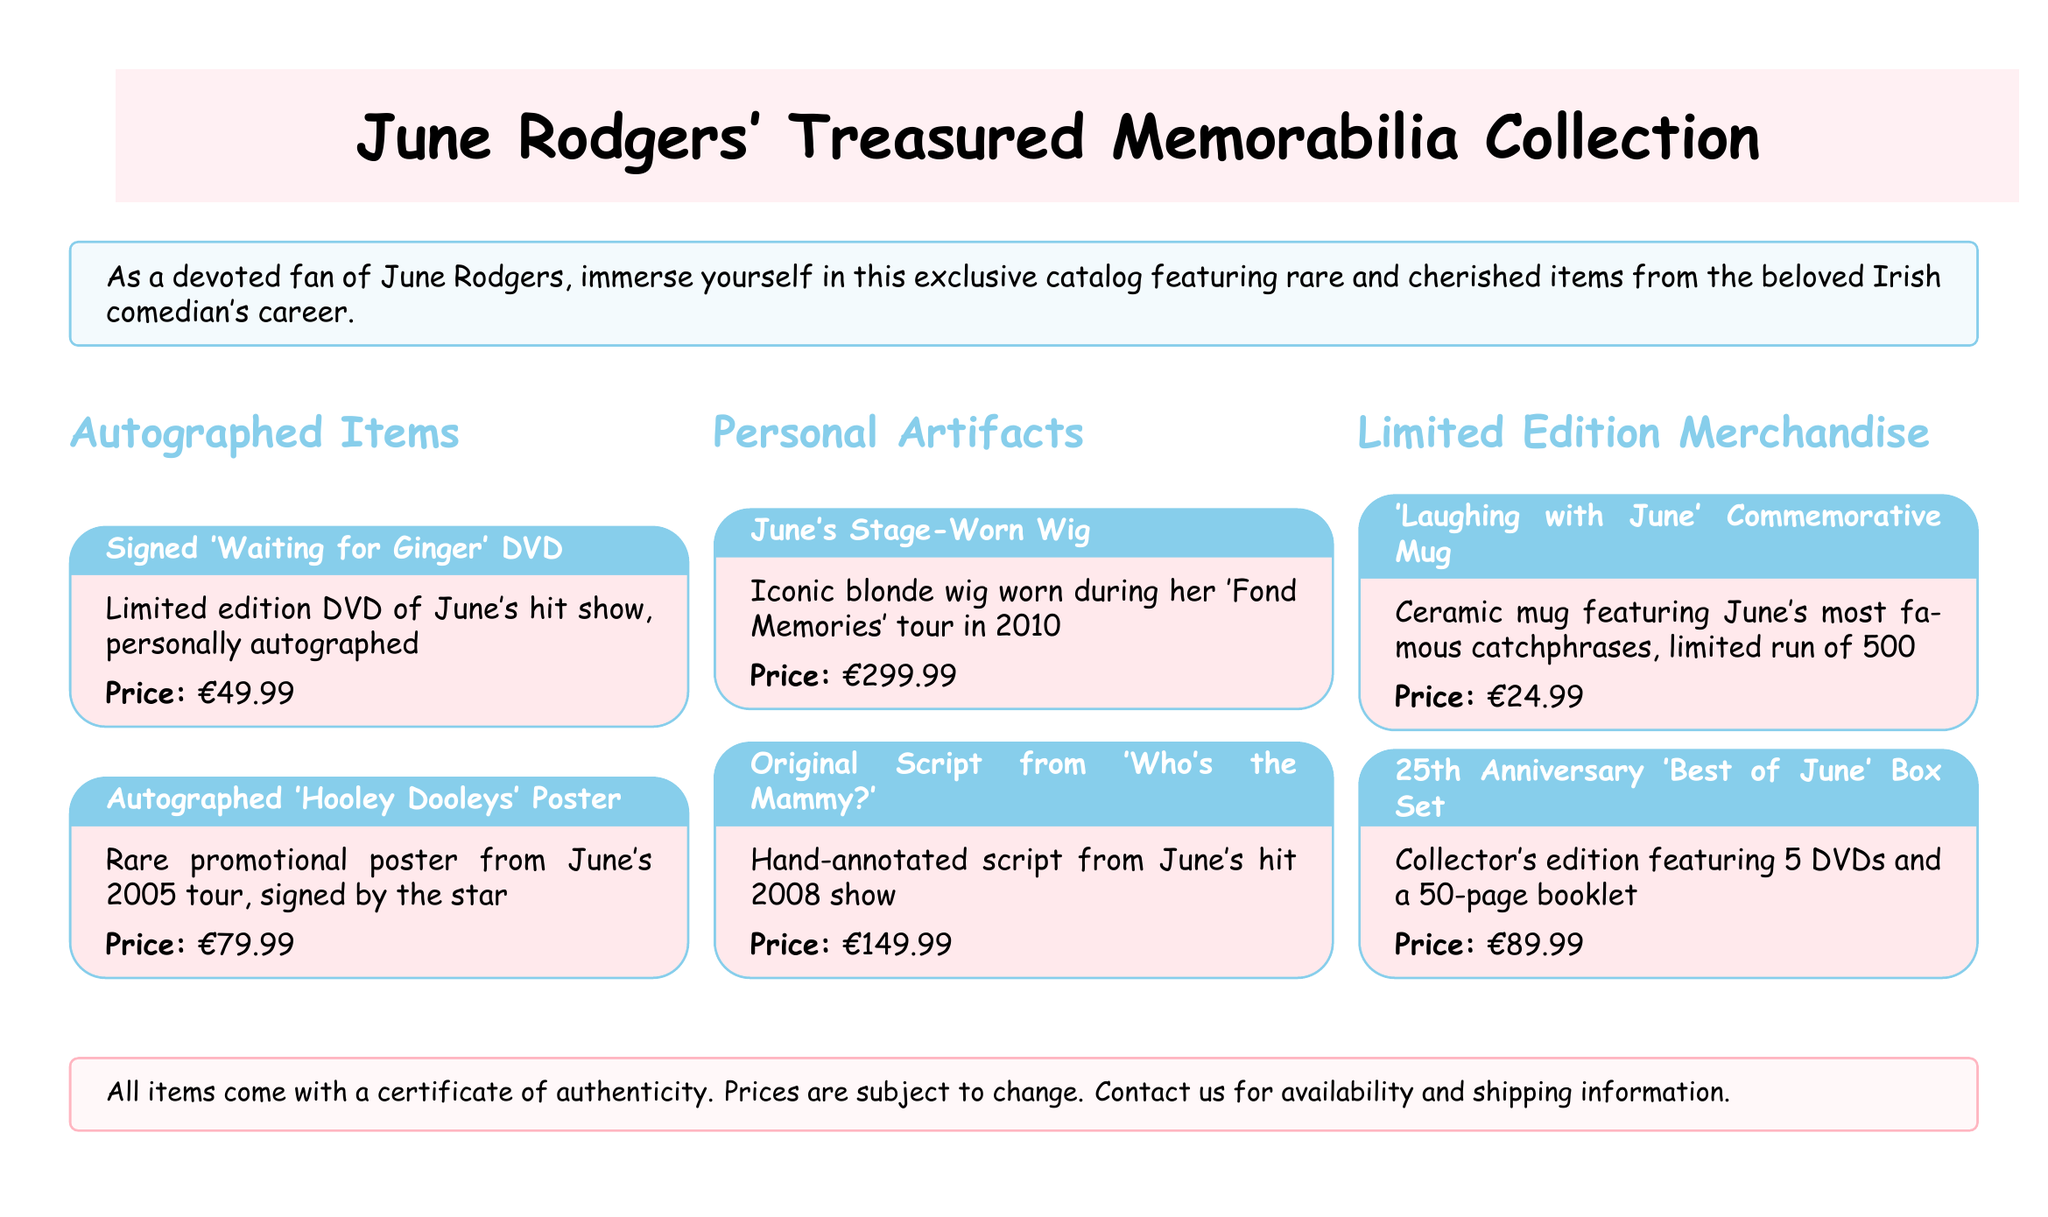What is the price of the signed 'Waiting for Ginger' DVD? The price is specifically listed next to the item in the catalog.
Answer: €49.99 What item features June's catchphrases? This item is described in the 'Limited Edition Merchandise' section of the catalog.
Answer: 'Laughing with June' Commemorative Mug How much does the 25th Anniversary 'Best of June' Box Set cost? The price is shown in association with the item in the catalog.
Answer: €89.99 What year did June's 'Hooley Dooleys' tour take place? The specific year of the tour is mentioned in the description of the signed poster.
Answer: 2005 Which item is a personal artifact from June's 'Fond Memories' tour? This is found in the 'Personal Artifacts' section and refers to an item worn on a specific tour.
Answer: June's Stage-Worn Wig How many DVDs are included in the collector's edition box set? The number of DVDs is included in the description of the box set.
Answer: 5 What is the total number of items listed in the autographed section? By counting the items described, we summarize the content of that section.
Answer: 2 Which item has a price of €299.99? The price is directly mentioned next to the item in the catalog.
Answer: June's Stage-Worn Wig 